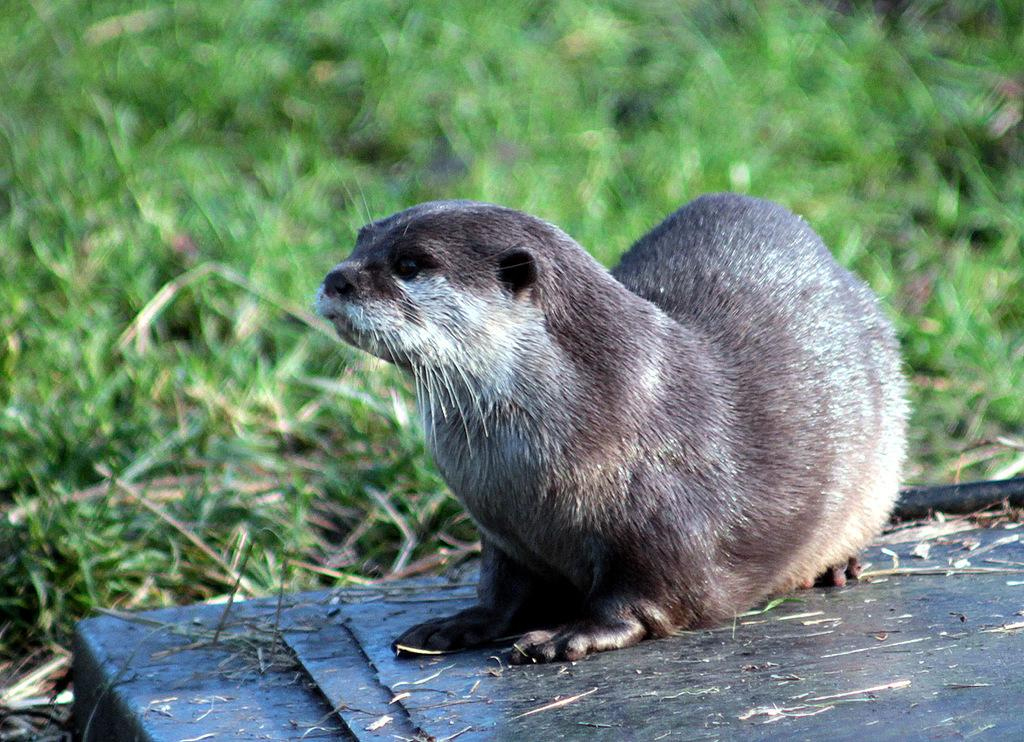What type of creature is in the image? There is an animal in the image. Where is the animal located? The animal is on the surface of something. What can be seen in the background of the image? There is grass visible in the background of the image. What type of goldfish can be seen swimming in the cornfield in the image? There is no goldfish or cornfield present in the image; it features an animal on the surface of something with grass visible in the background. 